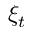<formula> <loc_0><loc_0><loc_500><loc_500>\xi _ { t }</formula> 